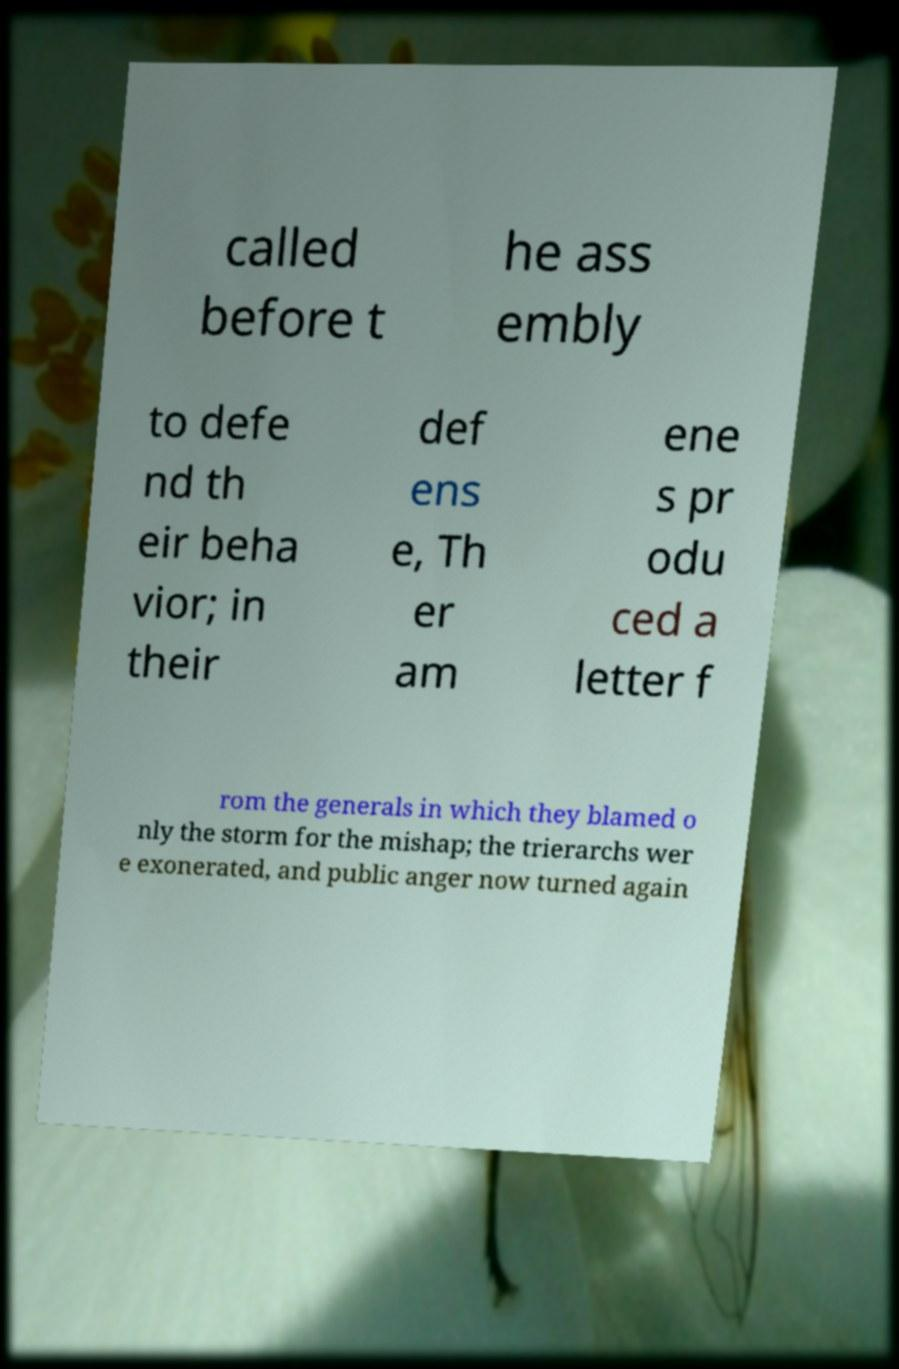Can you accurately transcribe the text from the provided image for me? called before t he ass embly to defe nd th eir beha vior; in their def ens e, Th er am ene s pr odu ced a letter f rom the generals in which they blamed o nly the storm for the mishap; the trierarchs wer e exonerated, and public anger now turned again 